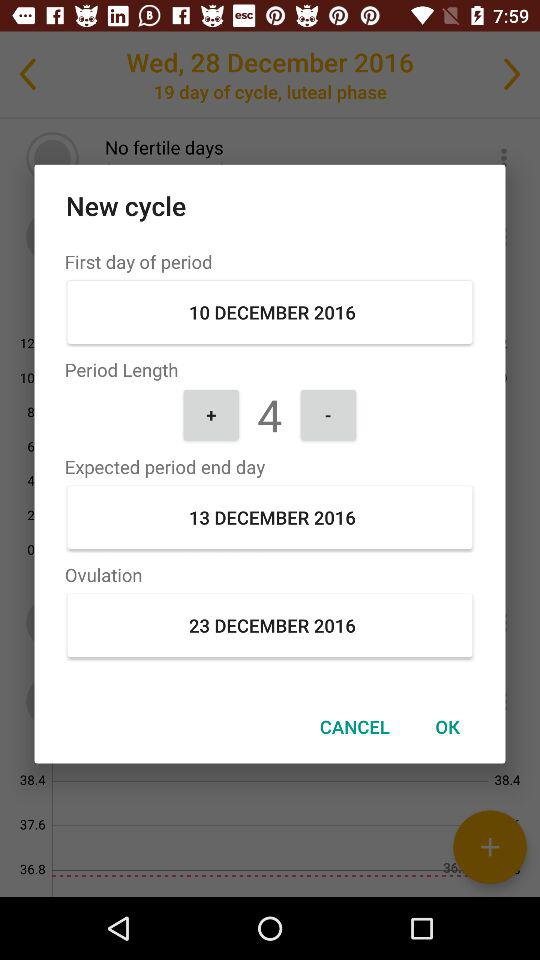What is the date of the "Ovulation"? The date of the "Ovulation" is December 23, 2016. 